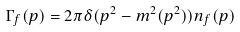Convert formula to latex. <formula><loc_0><loc_0><loc_500><loc_500>\Gamma _ { f } ( p ) = 2 \pi \delta ( p ^ { 2 } - m ^ { 2 } ( p ^ { 2 } ) ) n _ { f } ( p )</formula> 